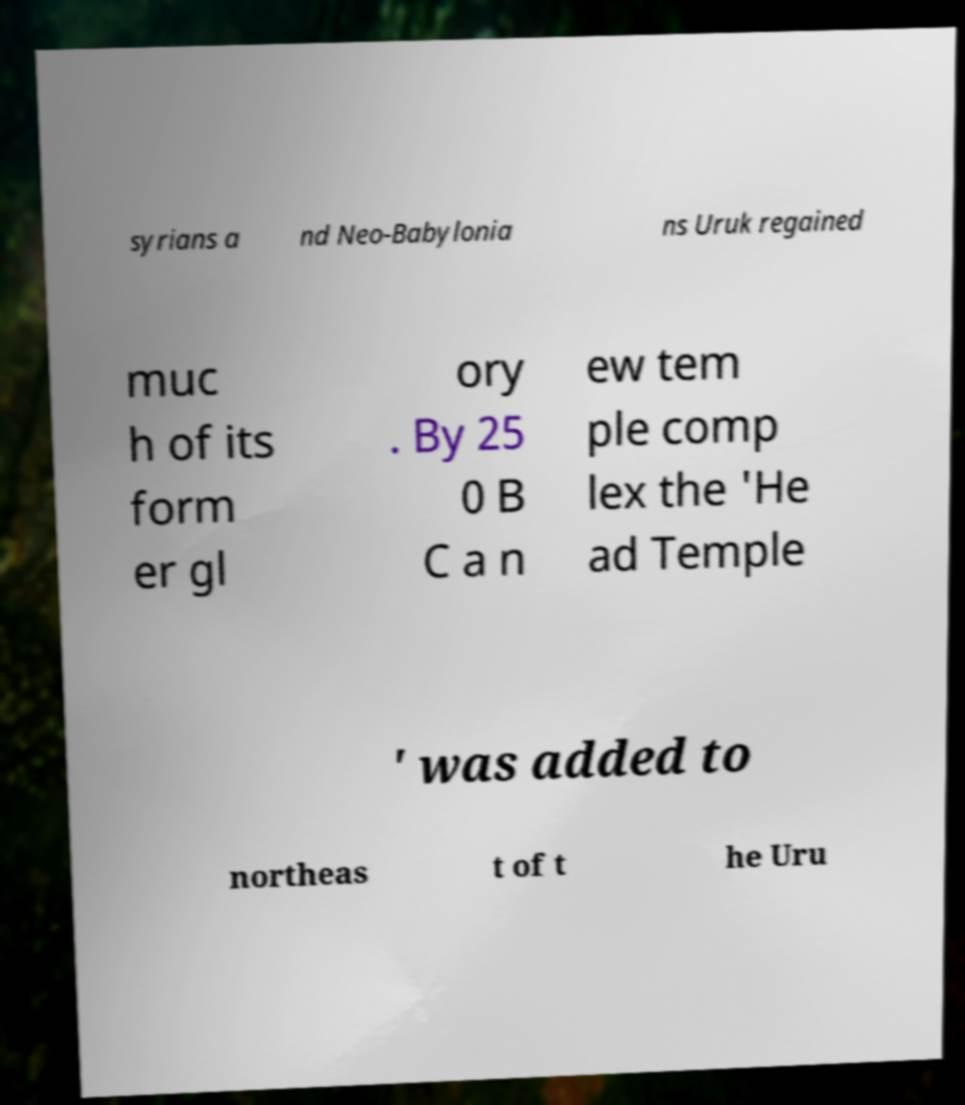Please identify and transcribe the text found in this image. syrians a nd Neo-Babylonia ns Uruk regained muc h of its form er gl ory . By 25 0 B C a n ew tem ple comp lex the 'He ad Temple ' was added to northeas t of t he Uru 